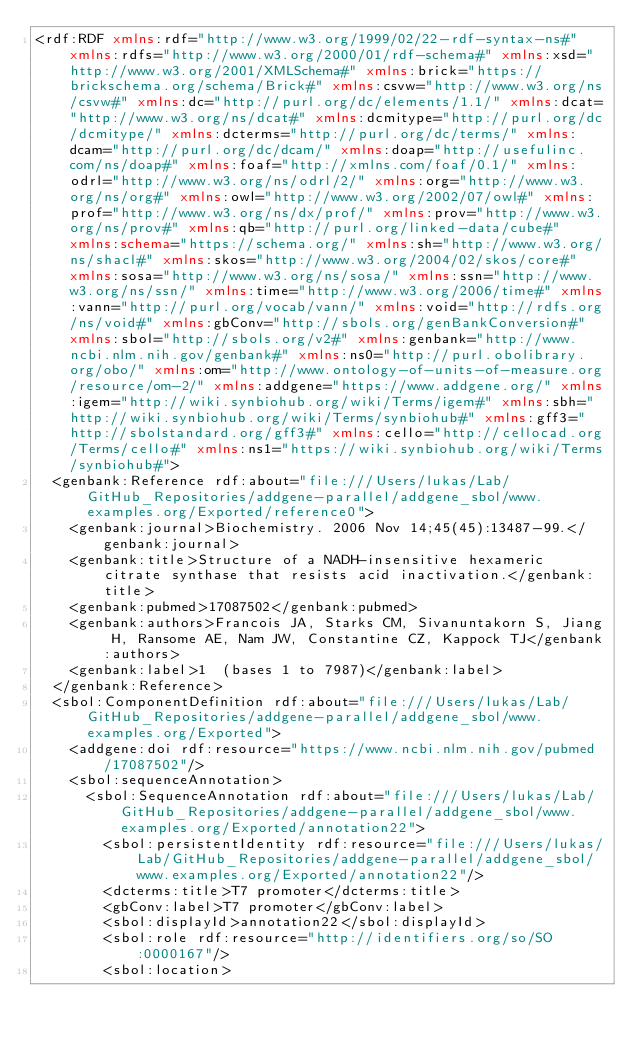Convert code to text. <code><loc_0><loc_0><loc_500><loc_500><_XML_><rdf:RDF xmlns:rdf="http://www.w3.org/1999/02/22-rdf-syntax-ns#" xmlns:rdfs="http://www.w3.org/2000/01/rdf-schema#" xmlns:xsd="http://www.w3.org/2001/XMLSchema#" xmlns:brick="https://brickschema.org/schema/Brick#" xmlns:csvw="http://www.w3.org/ns/csvw#" xmlns:dc="http://purl.org/dc/elements/1.1/" xmlns:dcat="http://www.w3.org/ns/dcat#" xmlns:dcmitype="http://purl.org/dc/dcmitype/" xmlns:dcterms="http://purl.org/dc/terms/" xmlns:dcam="http://purl.org/dc/dcam/" xmlns:doap="http://usefulinc.com/ns/doap#" xmlns:foaf="http://xmlns.com/foaf/0.1/" xmlns:odrl="http://www.w3.org/ns/odrl/2/" xmlns:org="http://www.w3.org/ns/org#" xmlns:owl="http://www.w3.org/2002/07/owl#" xmlns:prof="http://www.w3.org/ns/dx/prof/" xmlns:prov="http://www.w3.org/ns/prov#" xmlns:qb="http://purl.org/linked-data/cube#" xmlns:schema="https://schema.org/" xmlns:sh="http://www.w3.org/ns/shacl#" xmlns:skos="http://www.w3.org/2004/02/skos/core#" xmlns:sosa="http://www.w3.org/ns/sosa/" xmlns:ssn="http://www.w3.org/ns/ssn/" xmlns:time="http://www.w3.org/2006/time#" xmlns:vann="http://purl.org/vocab/vann/" xmlns:void="http://rdfs.org/ns/void#" xmlns:gbConv="http://sbols.org/genBankConversion#" xmlns:sbol="http://sbols.org/v2#" xmlns:genbank="http://www.ncbi.nlm.nih.gov/genbank#" xmlns:ns0="http://purl.obolibrary.org/obo/" xmlns:om="http://www.ontology-of-units-of-measure.org/resource/om-2/" xmlns:addgene="https://www.addgene.org/" xmlns:igem="http://wiki.synbiohub.org/wiki/Terms/igem#" xmlns:sbh="http://wiki.synbiohub.org/wiki/Terms/synbiohub#" xmlns:gff3="http://sbolstandard.org/gff3#" xmlns:cello="http://cellocad.org/Terms/cello#" xmlns:ns1="https://wiki.synbiohub.org/wiki/Terms/synbiohub#">
  <genbank:Reference rdf:about="file:///Users/lukas/Lab/GitHub_Repositories/addgene-parallel/addgene_sbol/www.examples.org/Exported/reference0">
    <genbank:journal>Biochemistry. 2006 Nov 14;45(45):13487-99.</genbank:journal>
    <genbank:title>Structure of a NADH-insensitive hexameric citrate synthase that resists acid inactivation.</genbank:title>
    <genbank:pubmed>17087502</genbank:pubmed>
    <genbank:authors>Francois JA, Starks CM, Sivanuntakorn S, Jiang H, Ransome AE, Nam JW, Constantine CZ, Kappock TJ</genbank:authors>
    <genbank:label>1  (bases 1 to 7987)</genbank:label>
  </genbank:Reference>
  <sbol:ComponentDefinition rdf:about="file:///Users/lukas/Lab/GitHub_Repositories/addgene-parallel/addgene_sbol/www.examples.org/Exported">
    <addgene:doi rdf:resource="https://www.ncbi.nlm.nih.gov/pubmed/17087502"/>
    <sbol:sequenceAnnotation>
      <sbol:SequenceAnnotation rdf:about="file:///Users/lukas/Lab/GitHub_Repositories/addgene-parallel/addgene_sbol/www.examples.org/Exported/annotation22">
        <sbol:persistentIdentity rdf:resource="file:///Users/lukas/Lab/GitHub_Repositories/addgene-parallel/addgene_sbol/www.examples.org/Exported/annotation22"/>
        <dcterms:title>T7 promoter</dcterms:title>
        <gbConv:label>T7 promoter</gbConv:label>
        <sbol:displayId>annotation22</sbol:displayId>
        <sbol:role rdf:resource="http://identifiers.org/so/SO:0000167"/>
        <sbol:location></code> 